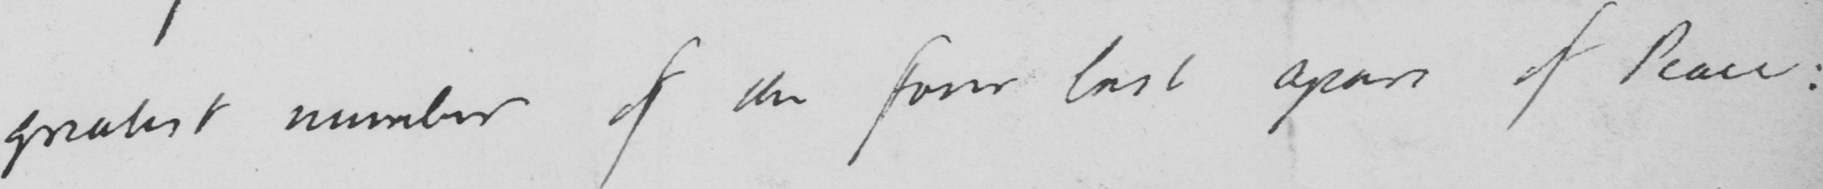Can you read and transcribe this handwriting? greatest number of the four last years of Peace: 